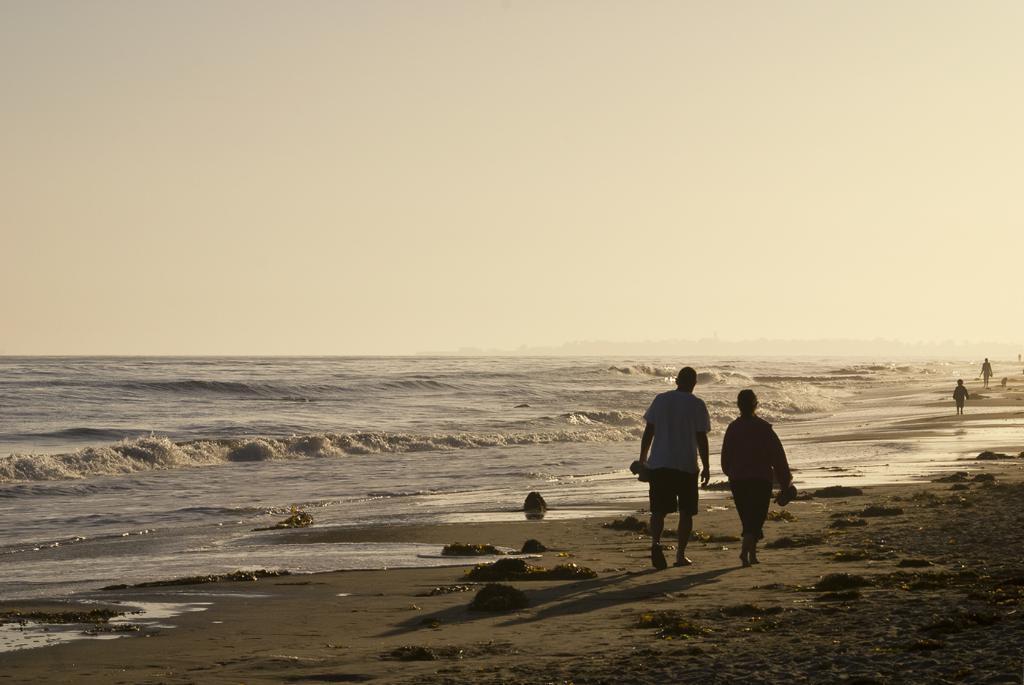Please provide a concise description of this image. Here in this picture we can see some people walking on the ground over there and beside them we can see water present all over there. 